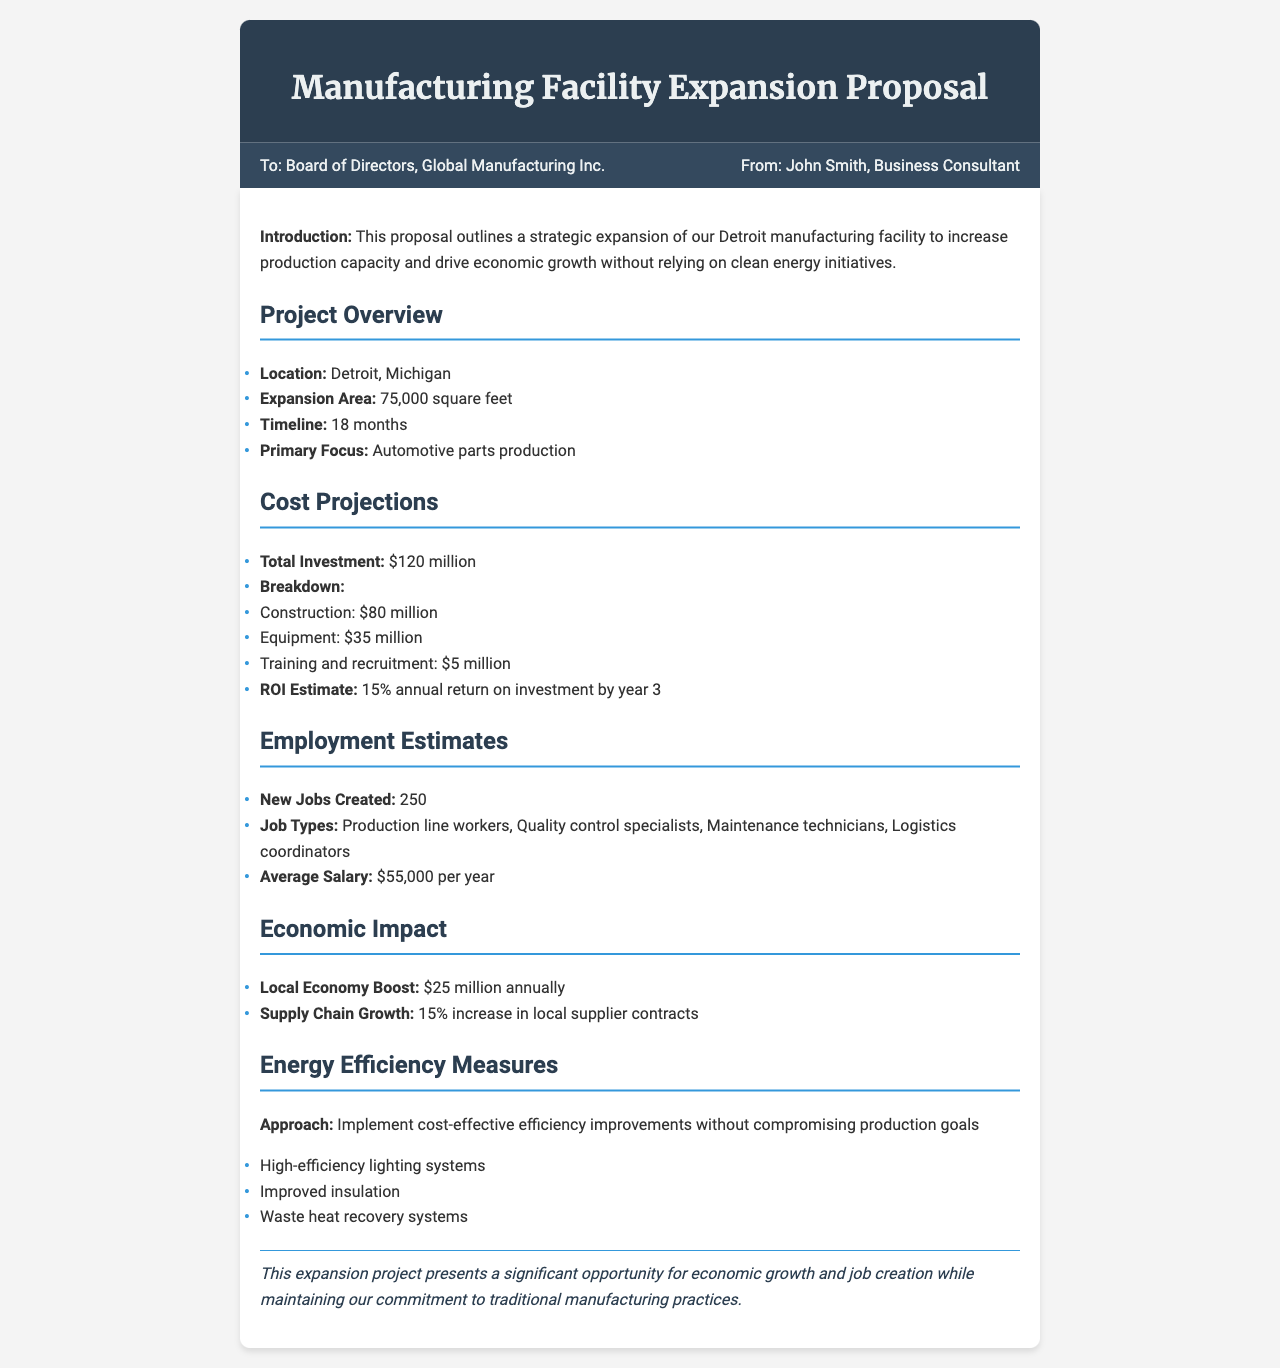what is the total investment? The total investment is explicitly stated in the document under cost projections.
Answer: $120 million what is the primary focus of the expansion? The primary focus is mentioned in the project overview section of the document.
Answer: Automotive parts production how many new jobs will be created? The number of new jobs is provided in the employment estimates section.
Answer: 250 what is the average salary for the new jobs? The average salary is detailed in the employment estimates section.
Answer: $55,000 per year what is the timeline for the project? The timeline for the project is provided in the project overview.
Answer: 18 months how much will be spent on construction? The amount allocated for construction is found in the cost projections section.
Answer: $80 million what is the estimated annual return on investment? The ROI estimate is specified in the cost projections section of the document.
Answer: 15% what is the expected local economy boost? The local economy boost is stated in the economic impact section.
Answer: $25 million annually what types of jobs will be created? The job types are listed in the employment estimates section of the document.
Answer: Production line workers, Quality control specialists, Maintenance technicians, Logistics coordinators 